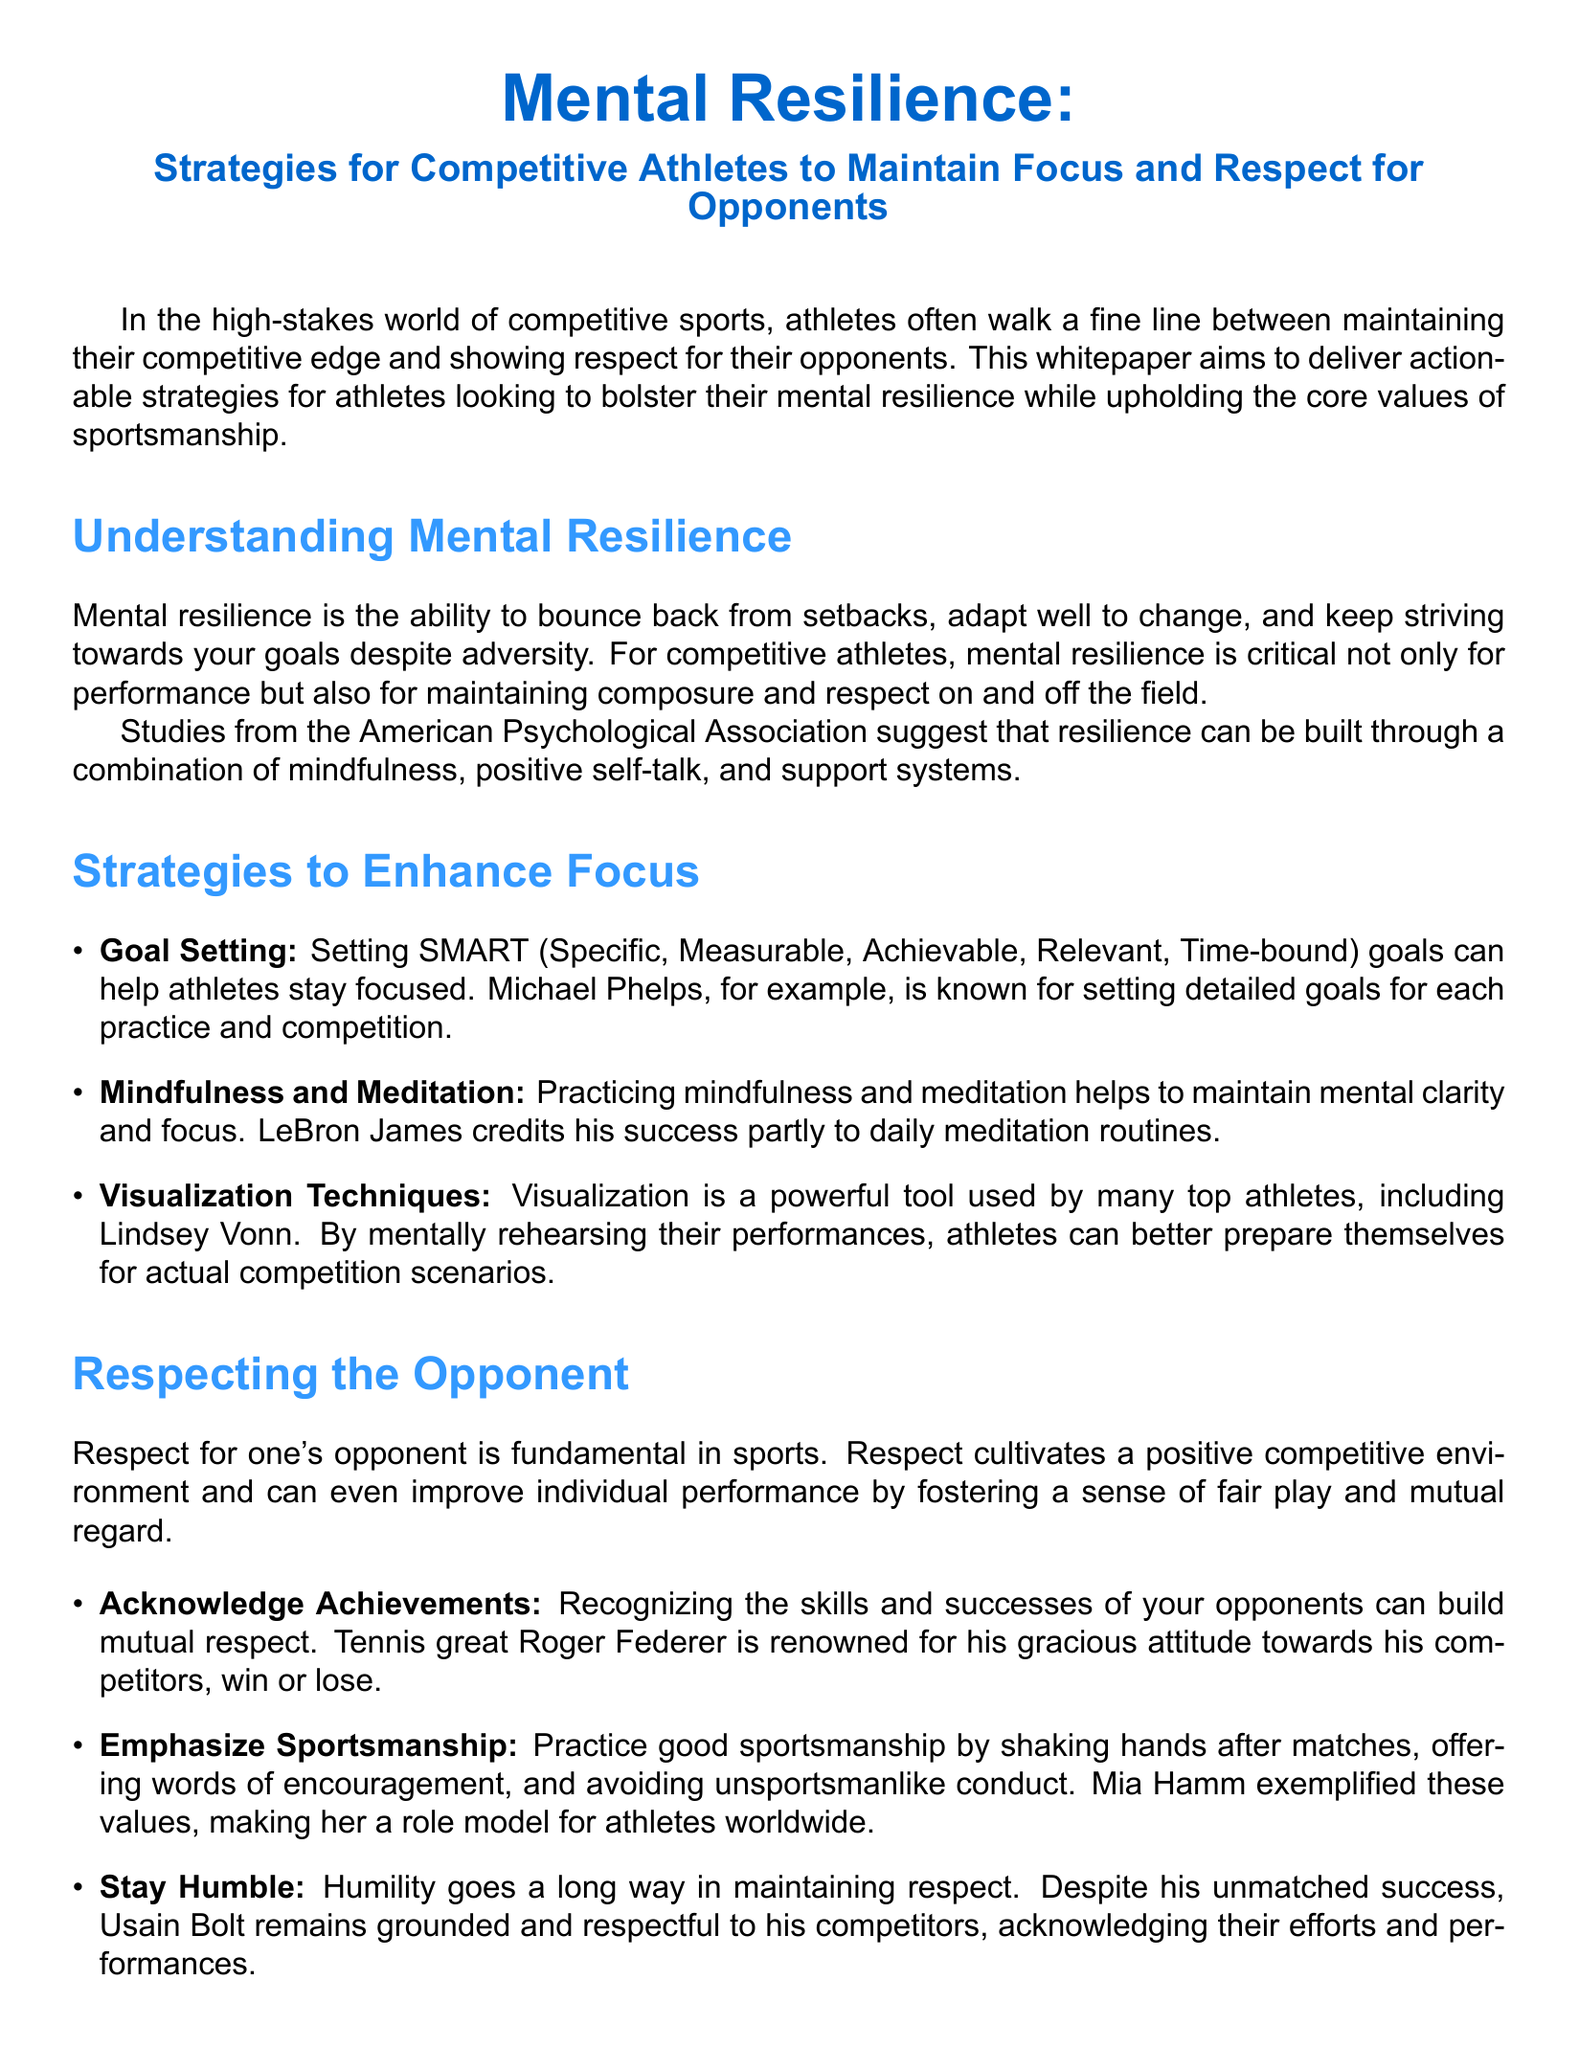What is the main topic of the whitepaper? The main topic is about strategies for competitive athletes to maintain focus and respect for opponents.
Answer: Mental Resilience What does SMART stand for in goal setting? The acronym SMART stands for Specific, Measurable, Achievable, Relevant, and Time-bound.
Answer: Specific, Measurable, Achievable, Relevant, Time-bound Who is known for daily meditation routines? The whitepaper mentions this athlete in relation to mindfulness and meditation.
Answer: LeBron James What is one way to build mental resilience according to the document? The document suggests several ways to build mental resilience, including practicing mindfulness.
Answer: Mindfulness Which tennis player is acknowledged for a gracious attitude towards competitors? The whitepaper provides an example of this tennis player to illustrate respect for opponents.
Answer: Roger Federer What is emphasized in the section about Respecting the Opponent? This section includes strategies to show respect towards opponents in competitive sports.
Answer: Acknowledge Achievements What characteristic does Usain Bolt exhibit according to the document? The whitepaper points out how Usain Bolt maintains a positive attitude despite his achievements.
Answer: Humility What kind of document is this? The structure and intent of the document are common for a specific type of scholarly writing in sports psychology.
Answer: Whitepaper 